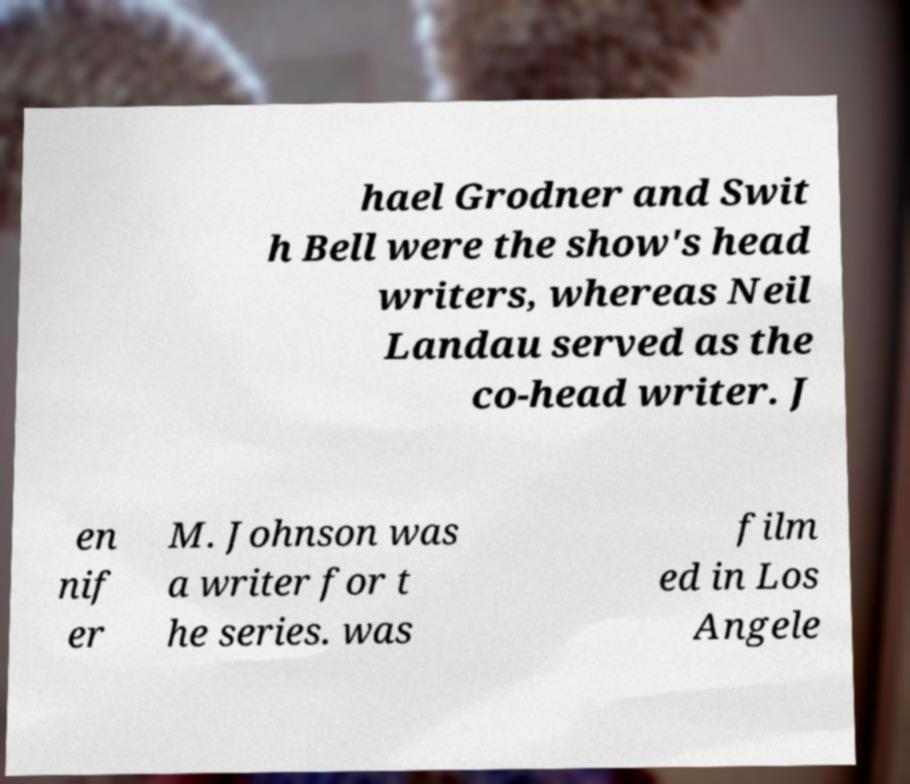Can you read and provide the text displayed in the image?This photo seems to have some interesting text. Can you extract and type it out for me? hael Grodner and Swit h Bell were the show's head writers, whereas Neil Landau served as the co-head writer. J en nif er M. Johnson was a writer for t he series. was film ed in Los Angele 